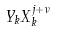<formula> <loc_0><loc_0><loc_500><loc_500>Y _ { k } X _ { k } ^ { j + \nu }</formula> 